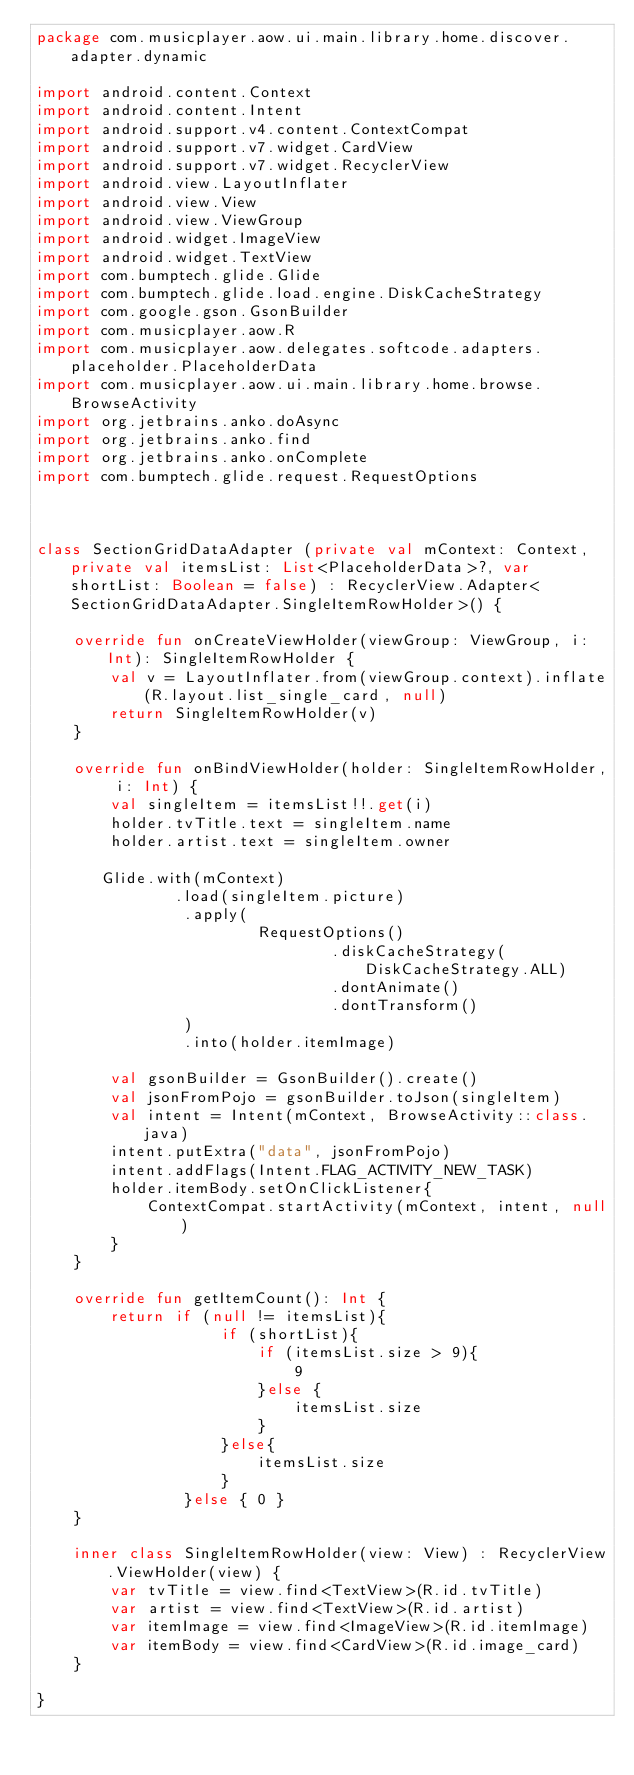Convert code to text. <code><loc_0><loc_0><loc_500><loc_500><_Kotlin_>package com.musicplayer.aow.ui.main.library.home.discover.adapter.dynamic

import android.content.Context
import android.content.Intent
import android.support.v4.content.ContextCompat
import android.support.v7.widget.CardView
import android.support.v7.widget.RecyclerView
import android.view.LayoutInflater
import android.view.View
import android.view.ViewGroup
import android.widget.ImageView
import android.widget.TextView
import com.bumptech.glide.Glide
import com.bumptech.glide.load.engine.DiskCacheStrategy
import com.google.gson.GsonBuilder
import com.musicplayer.aow.R
import com.musicplayer.aow.delegates.softcode.adapters.placeholder.PlaceholderData
import com.musicplayer.aow.ui.main.library.home.browse.BrowseActivity
import org.jetbrains.anko.doAsync
import org.jetbrains.anko.find
import org.jetbrains.anko.onComplete
import com.bumptech.glide.request.RequestOptions



class SectionGridDataAdapter (private val mContext: Context, private val itemsList: List<PlaceholderData>?, var shortList: Boolean = false) : RecyclerView.Adapter<SectionGridDataAdapter.SingleItemRowHolder>() {

    override fun onCreateViewHolder(viewGroup: ViewGroup, i: Int): SingleItemRowHolder {
        val v = LayoutInflater.from(viewGroup.context).inflate(R.layout.list_single_card, null)
        return SingleItemRowHolder(v)
    }

    override fun onBindViewHolder(holder: SingleItemRowHolder, i: Int) {
        val singleItem = itemsList!!.get(i)
        holder.tvTitle.text = singleItem.name
        holder.artist.text = singleItem.owner

       Glide.with(mContext)
               .load(singleItem.picture)
                .apply(
                        RequestOptions()
                                .diskCacheStrategy(DiskCacheStrategy.ALL)
                                .dontAnimate()
                                .dontTransform()
                )
                .into(holder.itemImage)

        val gsonBuilder = GsonBuilder().create()
        val jsonFromPojo = gsonBuilder.toJson(singleItem)
        val intent = Intent(mContext, BrowseActivity::class.java)
        intent.putExtra("data", jsonFromPojo)
        intent.addFlags(Intent.FLAG_ACTIVITY_NEW_TASK)
        holder.itemBody.setOnClickListener{
            ContextCompat.startActivity(mContext, intent, null)
        }
    }

    override fun getItemCount(): Int {
        return if (null != itemsList){
                    if (shortList){
                        if (itemsList.size > 9){
                            9
                        }else {
                            itemsList.size
                        }
                    }else{
                        itemsList.size
                    }
                }else { 0 }
    }

    inner class SingleItemRowHolder(view: View) : RecyclerView.ViewHolder(view) {
        var tvTitle = view.find<TextView>(R.id.tvTitle)
        var artist = view.find<TextView>(R.id.artist)
        var itemImage = view.find<ImageView>(R.id.itemImage)
        var itemBody = view.find<CardView>(R.id.image_card)
    }

}</code> 